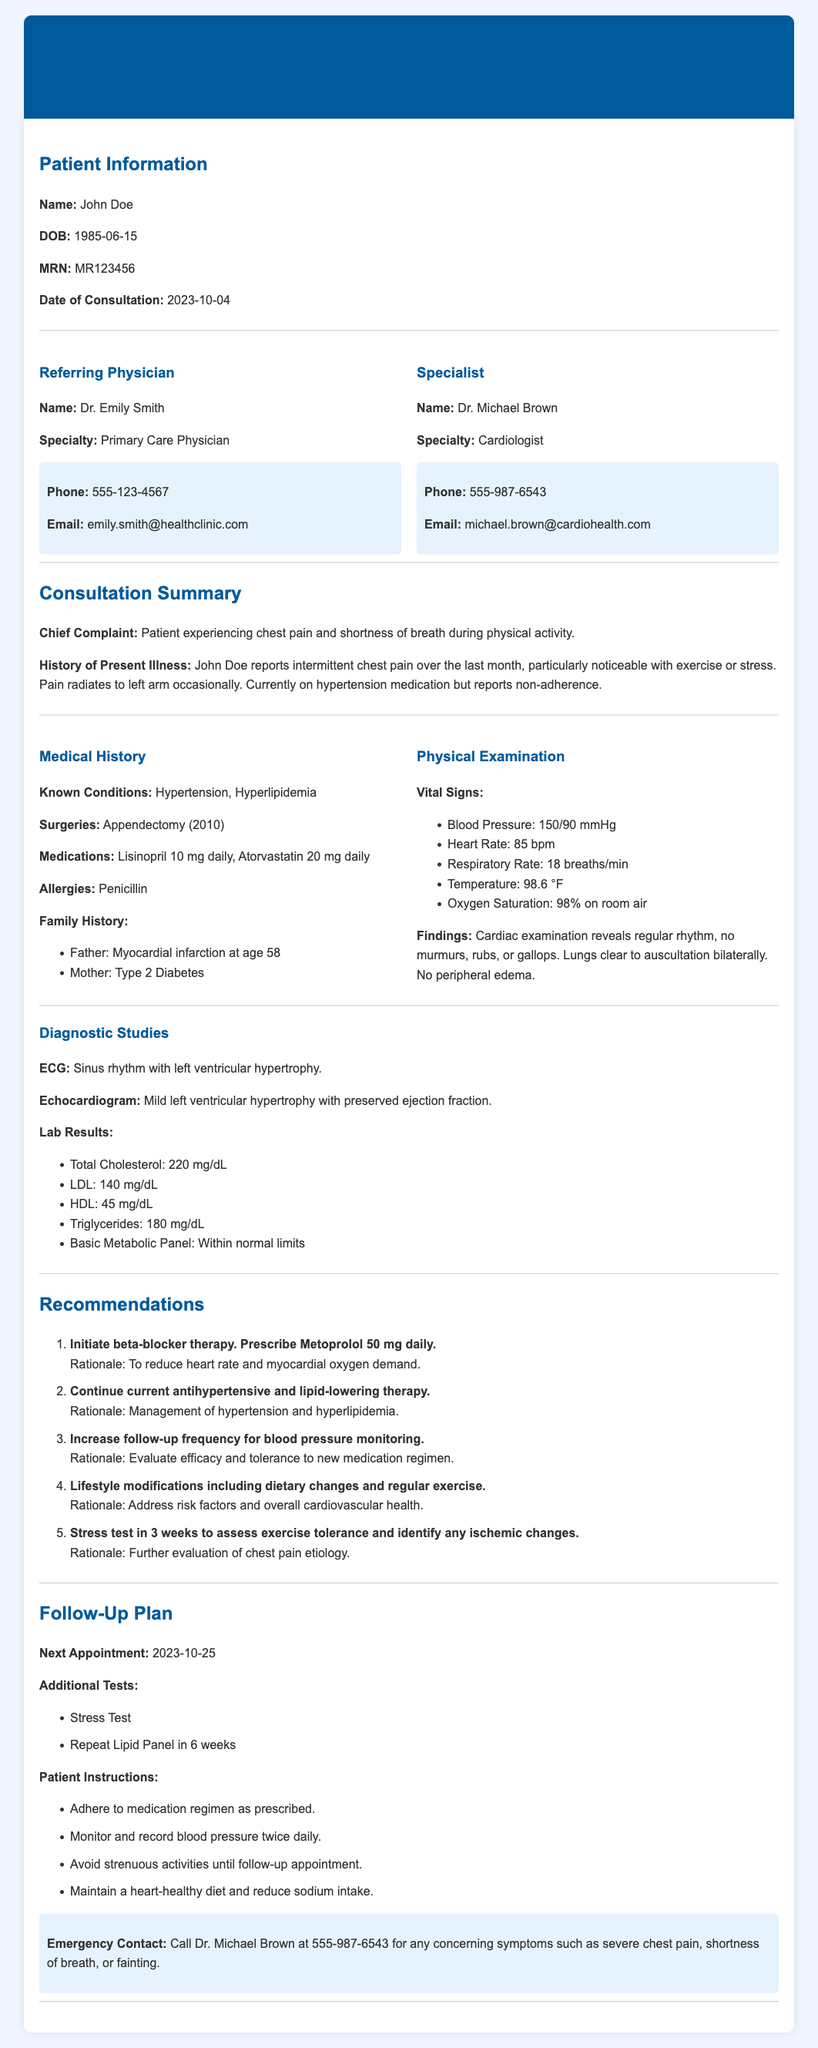What is the patient's name? The patient's name is listed in the Patient Information section of the document.
Answer: John Doe Who is the referring physician? The name of the referring physician is found in the section detailing the healthcare providers.
Answer: Dr. Emily Smith What is the chief complaint? The chief complaint is a brief description of the patient's main issue and is found in the Consultation Summary.
Answer: Patient experiencing chest pain and shortness of breath during physical activity What is the next appointment date? The date for the next appointment is specified in the Follow-Up Plan section.
Answer: 2023-10-25 What medication is being prescribed to the patient? The specific medication prescribed is mentioned in the Recommendations section.
Answer: Metoprolol 50 mg daily What are the patient's known conditions? Known conditions are listed in the Medical History section.
Answer: Hypertension, Hyperlipidemia What test is recommended in three weeks? The test is mentioned in the Recommendations section and is linked to the patient's symptoms.
Answer: Stress test What should the patient avoid until the follow-up appointment? The information regarding what to avoid is in the Patient Instructions within the Follow-Up Plan.
Answer: Strenuous activities What family history is noted in the document? Family history details are provided in the Medical History section, mentioning health conditions of family members.
Answer: Father: Myocardial infarction at age 58, Mother: Type 2 Diabetes 